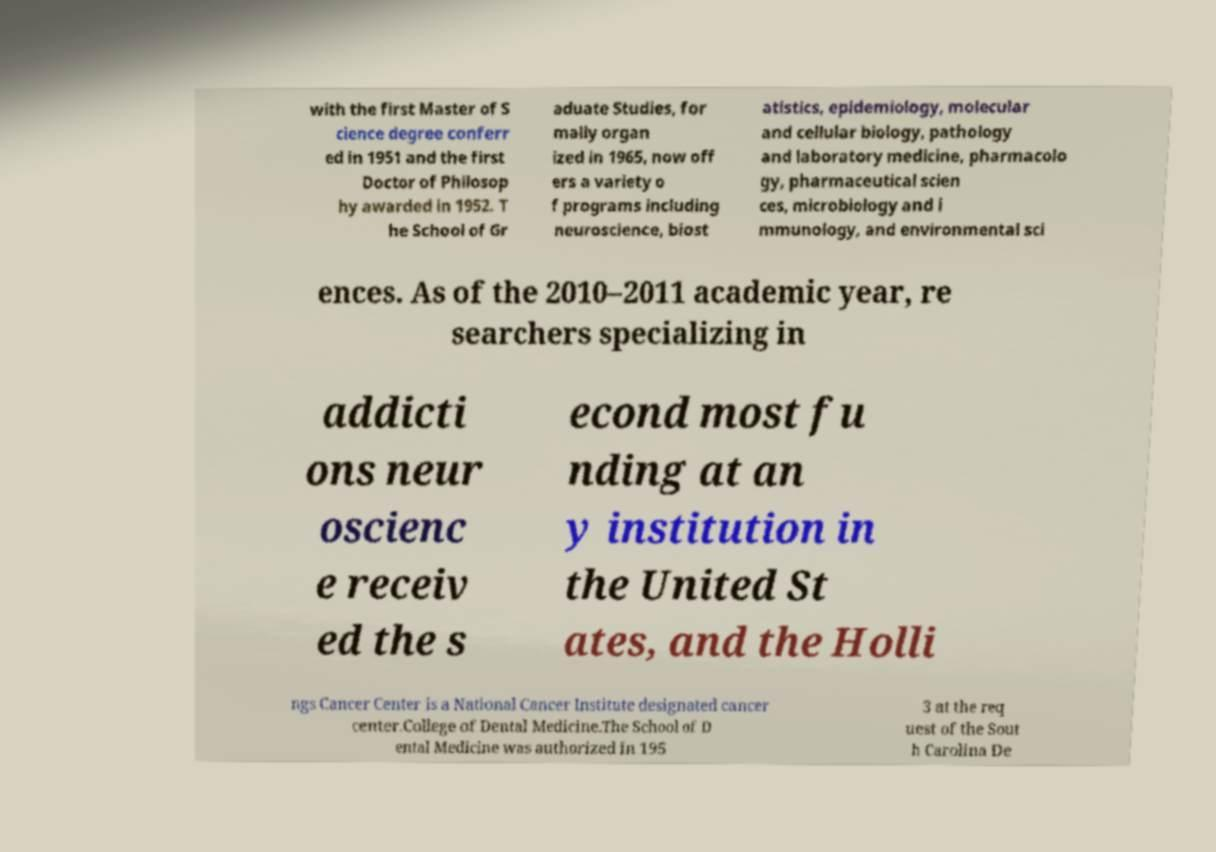Please read and relay the text visible in this image. What does it say? with the first Master of S cience degree conferr ed in 1951 and the first Doctor of Philosop hy awarded in 1952. T he School of Gr aduate Studies, for mally organ ized in 1965, now off ers a variety o f programs including neuroscience, biost atistics, epidemiology, molecular and cellular biology, pathology and laboratory medicine, pharmacolo gy, pharmaceutical scien ces, microbiology and i mmunology, and environmental sci ences. As of the 2010–2011 academic year, re searchers specializing in addicti ons neur oscienc e receiv ed the s econd most fu nding at an y institution in the United St ates, and the Holli ngs Cancer Center is a National Cancer Institute designated cancer center.College of Dental Medicine.The School of D ental Medicine was authorized in 195 3 at the req uest of the Sout h Carolina De 